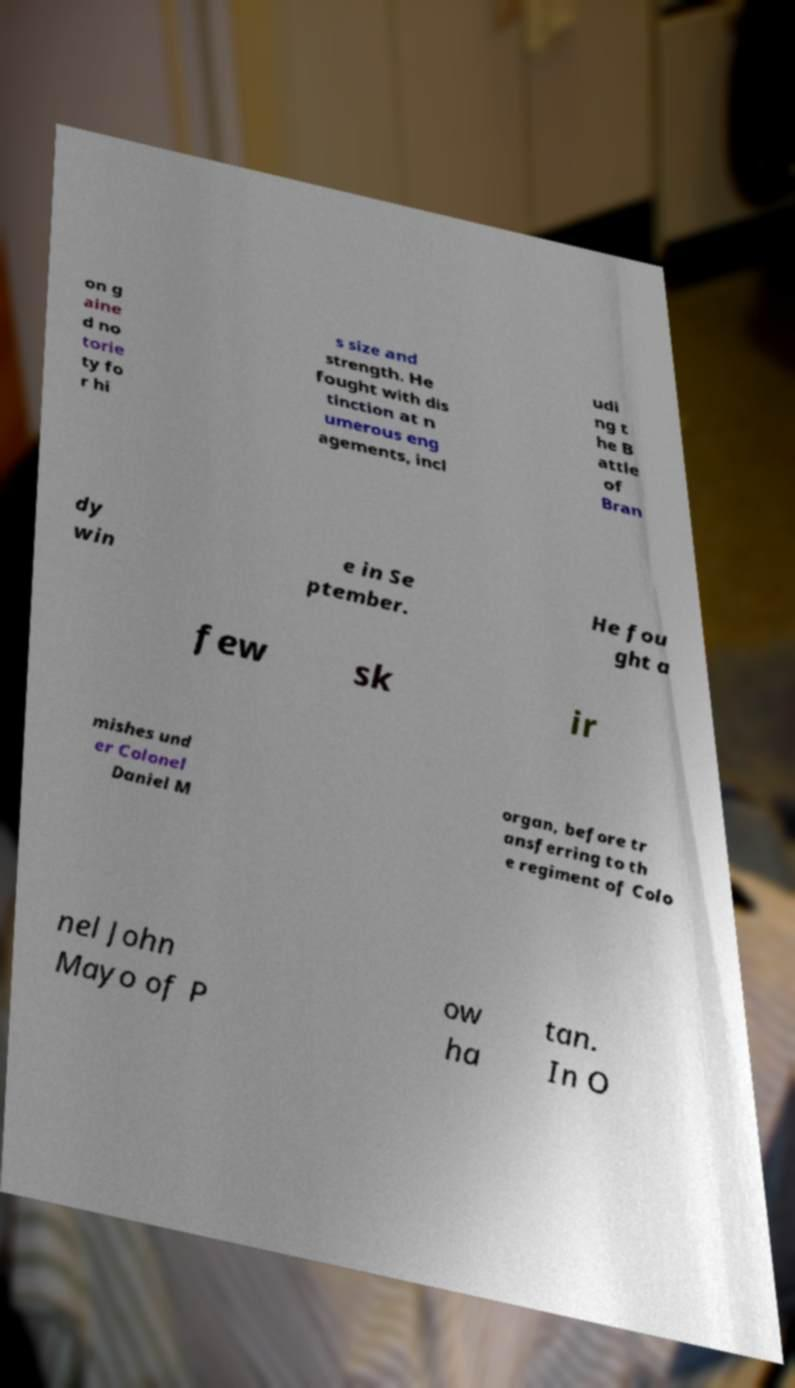Could you extract and type out the text from this image? on g aine d no torie ty fo r hi s size and strength. He fought with dis tinction at n umerous eng agements, incl udi ng t he B attle of Bran dy win e in Se ptember. He fou ght a few sk ir mishes und er Colonel Daniel M organ, before tr ansferring to th e regiment of Colo nel John Mayo of P ow ha tan. In O 